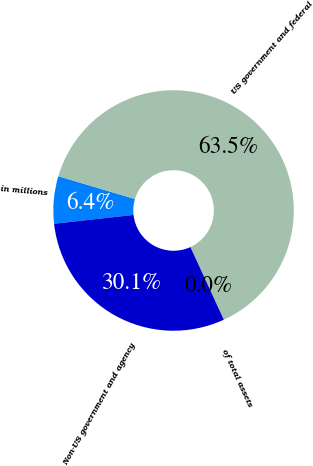Convert chart to OTSL. <chart><loc_0><loc_0><loc_500><loc_500><pie_chart><fcel>in millions<fcel>US government and federal<fcel>of total assets<fcel>Non-US government and agency<nl><fcel>6.36%<fcel>63.53%<fcel>0.01%<fcel>30.1%<nl></chart> 